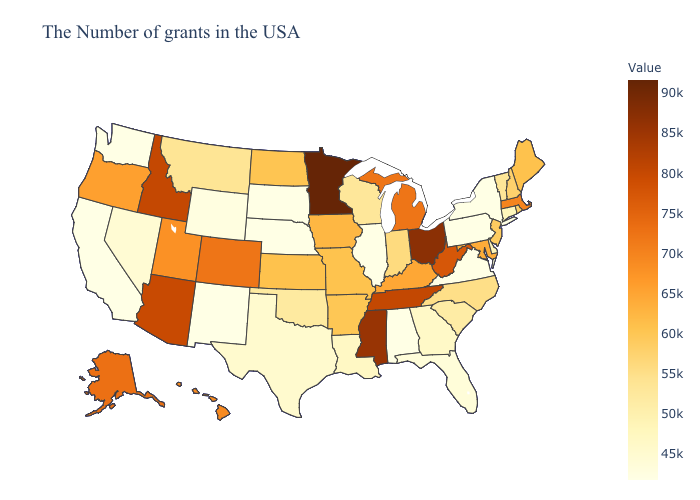Does Minnesota have the highest value in the USA?
Quick response, please. Yes. Does Iowa have a lower value than California?
Give a very brief answer. No. Does Nevada have the lowest value in the West?
Short answer required. No. Is the legend a continuous bar?
Short answer required. Yes. Among the states that border Alabama , which have the lowest value?
Concise answer only. Florida. Among the states that border Kansas , which have the lowest value?
Give a very brief answer. Nebraska. Which states have the highest value in the USA?
Quick response, please. Minnesota. Which states have the highest value in the USA?
Write a very short answer. Minnesota. Which states hav the highest value in the West?
Write a very short answer. Idaho. 